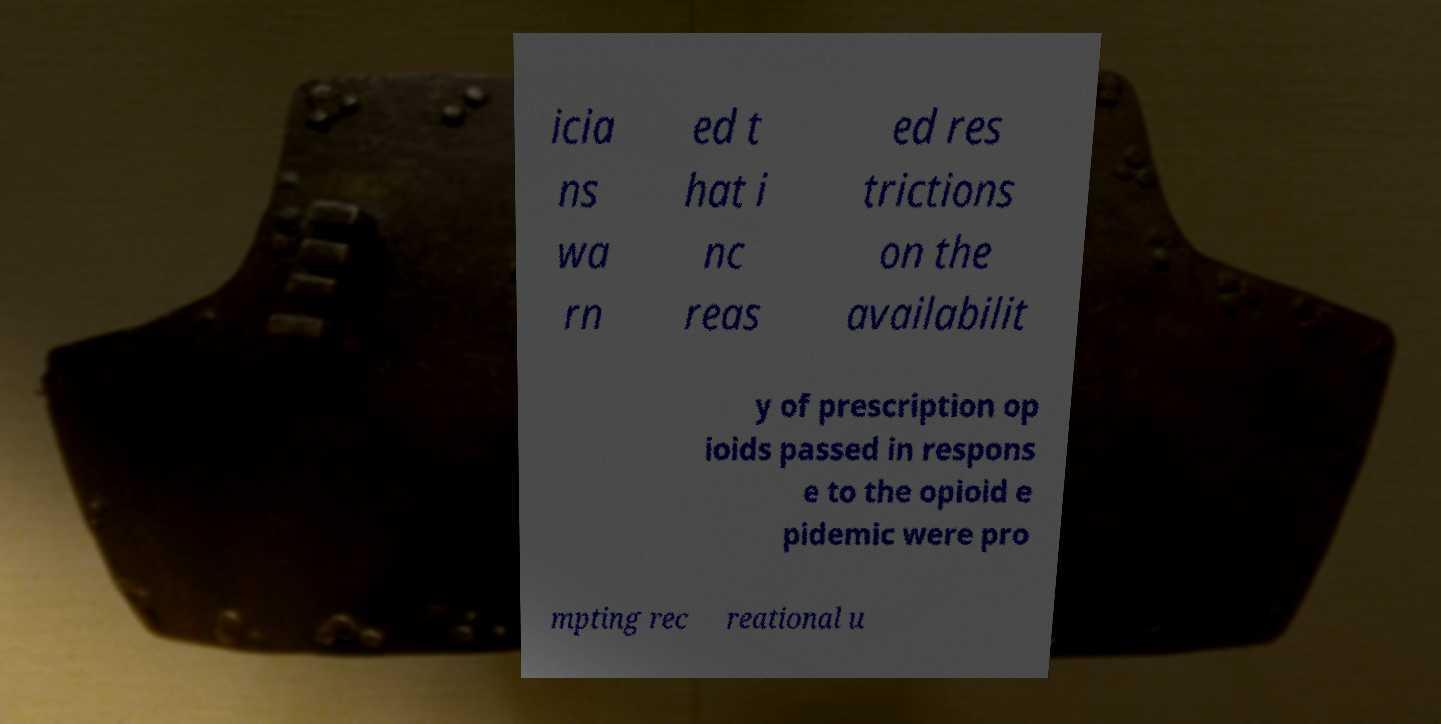There's text embedded in this image that I need extracted. Can you transcribe it verbatim? icia ns wa rn ed t hat i nc reas ed res trictions on the availabilit y of prescription op ioids passed in respons e to the opioid e pidemic were pro mpting rec reational u 